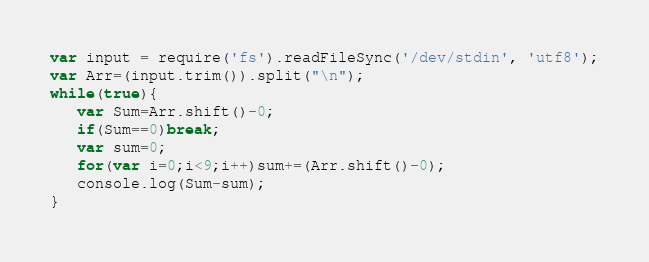<code> <loc_0><loc_0><loc_500><loc_500><_JavaScript_>var input = require('fs').readFileSync('/dev/stdin', 'utf8');
var Arr=(input.trim()).split("\n");
while(true){
   var Sum=Arr.shift()-0;
   if(Sum==0)break;
   var sum=0;
   for(var i=0;i<9;i++)sum+=(Arr.shift()-0);
   console.log(Sum-sum);
}</code> 